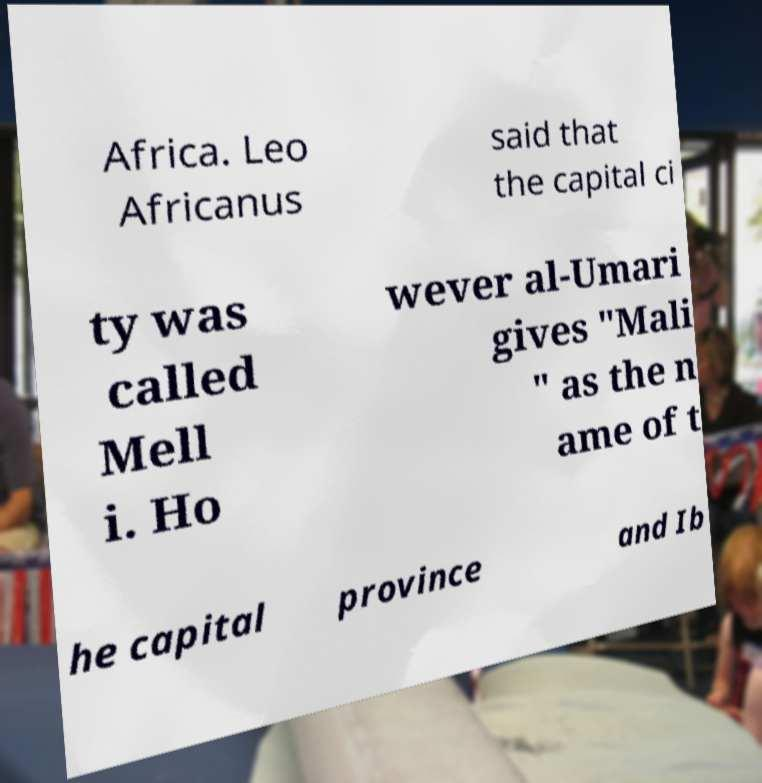Please read and relay the text visible in this image. What does it say? Africa. Leo Africanus said that the capital ci ty was called Mell i. Ho wever al-Umari gives "Mali " as the n ame of t he capital province and Ib 